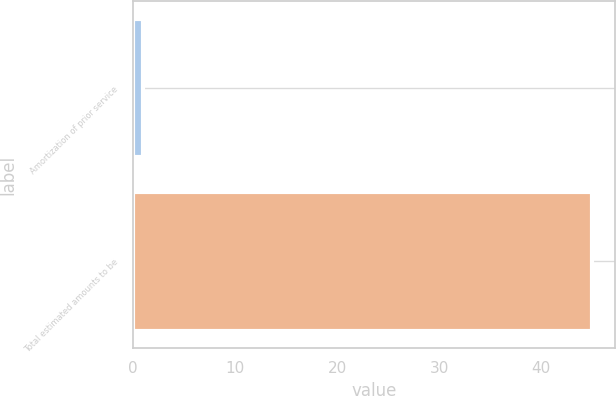<chart> <loc_0><loc_0><loc_500><loc_500><bar_chart><fcel>Amortization of prior service<fcel>Total estimated amounts to be<nl><fcel>1<fcel>45<nl></chart> 